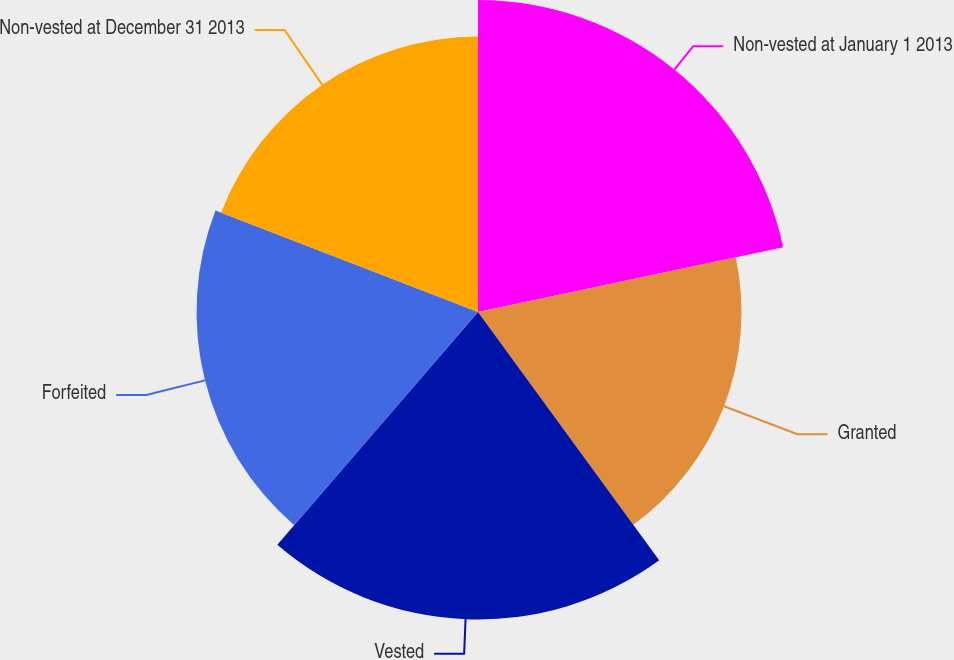Convert chart to OTSL. <chart><loc_0><loc_0><loc_500><loc_500><pie_chart><fcel>Non-vested at January 1 2013<fcel>Granted<fcel>Vested<fcel>Forfeited<fcel>Non-vested at December 31 2013<nl><fcel>21.67%<fcel>18.3%<fcel>21.35%<fcel>19.55%<fcel>19.13%<nl></chart> 